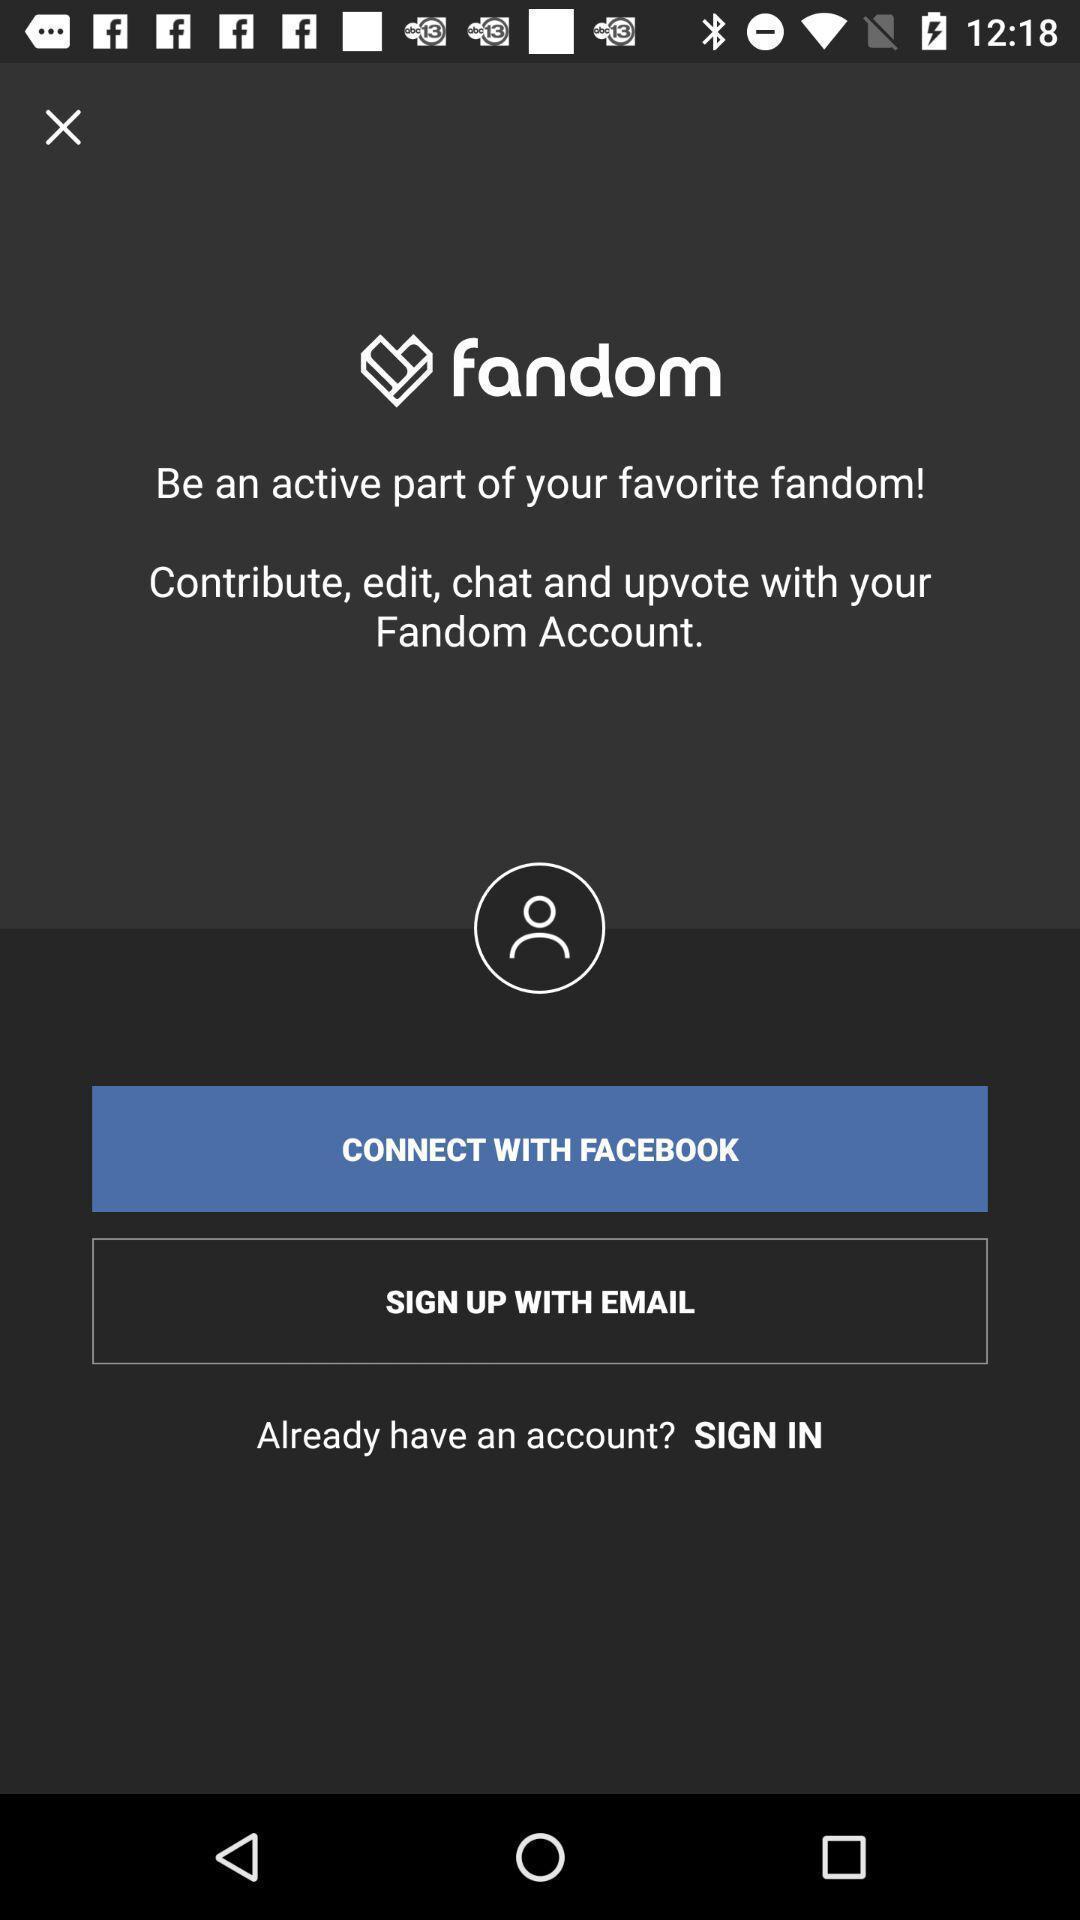Provide a description of this screenshot. Sign up page. 